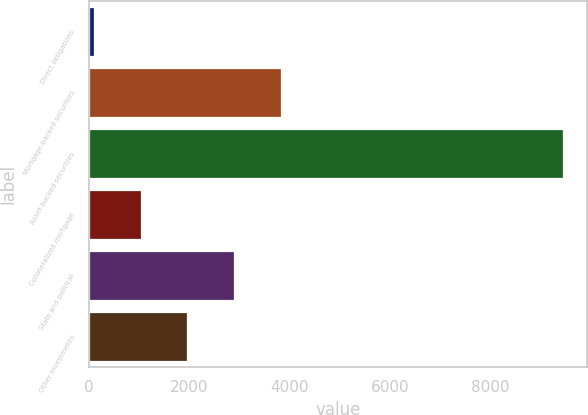Convert chart to OTSL. <chart><loc_0><loc_0><loc_500><loc_500><bar_chart><fcel>Direct obligations<fcel>Mortgage-backed securities<fcel>Asset-backed securities<fcel>Collateralized mortgage<fcel>State and political<fcel>Other investments<nl><fcel>88<fcel>3832.4<fcel>9449<fcel>1024.1<fcel>2896.3<fcel>1960.2<nl></chart> 